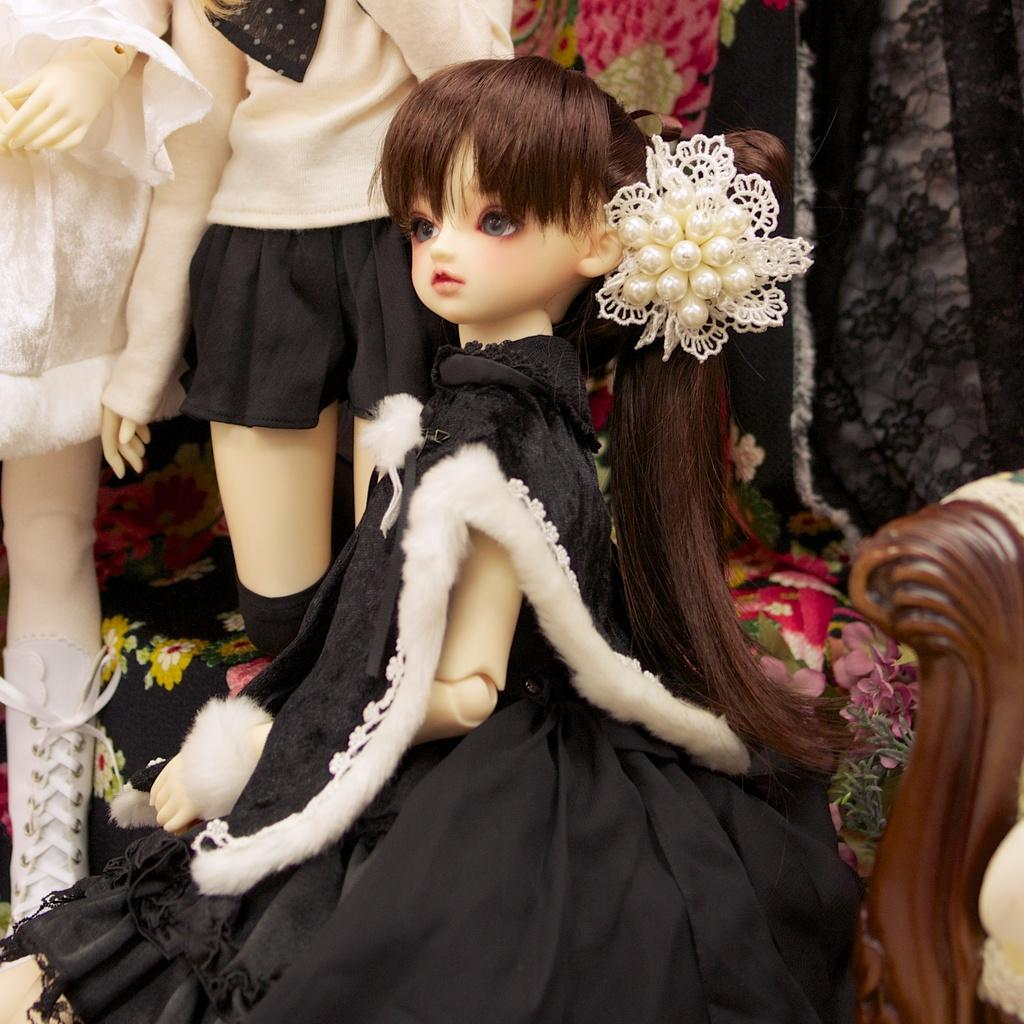How many dolls are present in the image? There are 3 dolls in the image. What can be observed about the dolls' appearance? The dolls have clothes on them. Are there any goldfish swimming in the dolls' clothes in the image? No, there are no goldfish present in the image, and the dolls' clothes do not contain any water for fish to swim in. 